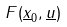Convert formula to latex. <formula><loc_0><loc_0><loc_500><loc_500>F ( \underline { x } _ { 0 } , \underline { u } )</formula> 